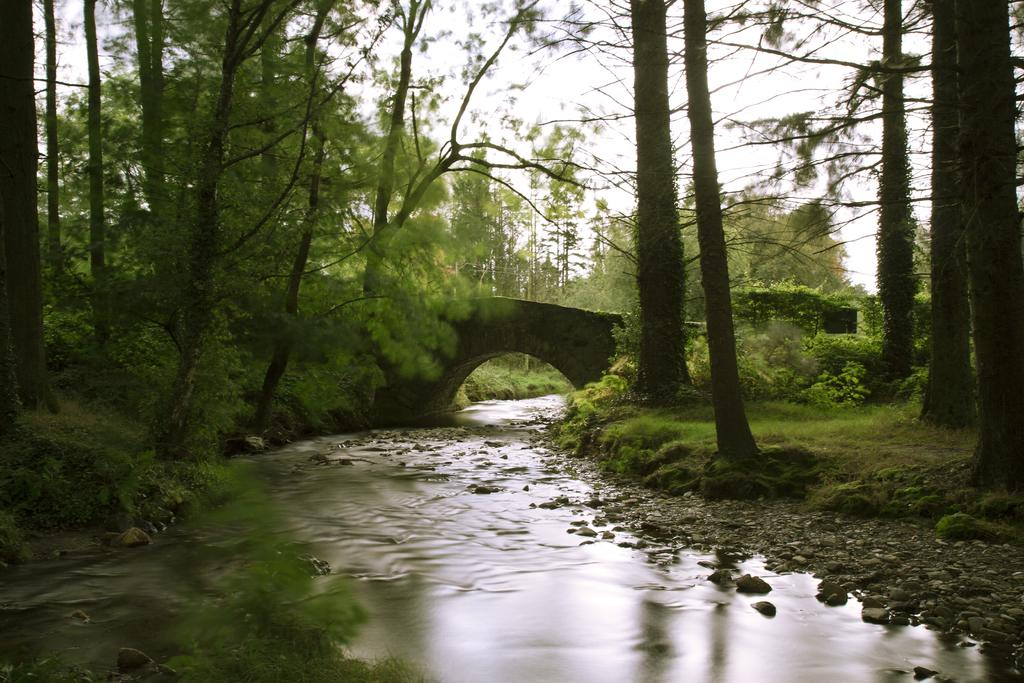What is at the bottom of the image? There is water at the bottom of the image. What type of vegetation can be seen in the image? There are trees in the image. What structure is present in the image? There is a bridge in the image. What is visible in the background of the image? The sky is visible in the background of the image. Where is the kite positioned in the image? There is no kite present in the image. What type of lock is used to secure the bridge in the image? There is no lock present in the image, as the bridge is not shown to be secured. 